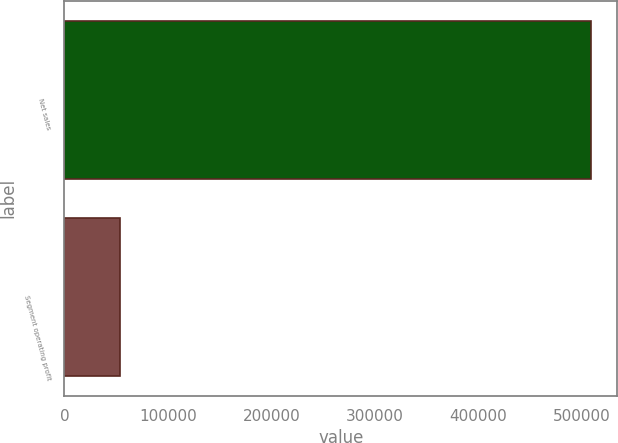<chart> <loc_0><loc_0><loc_500><loc_500><bar_chart><fcel>Net sales<fcel>Segment operating profit<nl><fcel>508372<fcel>53954<nl></chart> 